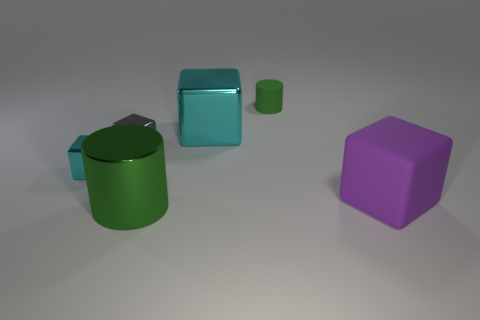How many other cylinders are the same color as the metallic cylinder?
Give a very brief answer. 1. How many cylinders are either tiny gray objects or large purple rubber things?
Your response must be concise. 0. There is a cyan thing that is to the right of the cyan thing in front of the large object that is behind the big purple matte object; what is its size?
Your answer should be very brief. Large. There is a large thing that is to the right of the green shiny cylinder and in front of the small cyan metallic block; what color is it?
Provide a short and direct response. Purple. There is a green matte cylinder; is its size the same as the cyan metallic block on the right side of the big metallic cylinder?
Provide a succinct answer. No. Are there any other things that are the same shape as the small green object?
Offer a very short reply. Yes. There is another large metallic object that is the same shape as the purple thing; what is its color?
Your response must be concise. Cyan. Do the green shiny thing and the purple block have the same size?
Make the answer very short. Yes. How many other objects are there of the same size as the green matte object?
Offer a terse response. 2. How many objects are cyan things that are right of the large green cylinder or cyan shiny cubes that are to the right of the small gray shiny cube?
Make the answer very short. 1. 